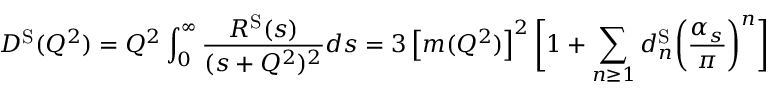<formula> <loc_0><loc_0><loc_500><loc_500>D ^ { S } ( Q ^ { 2 } ) = Q ^ { 2 } \int _ { 0 } ^ { \infty } \frac { R ^ { S } ( s ) } { ( s + Q ^ { 2 } ) ^ { 2 } } d s = 3 \left [ m ( Q ^ { 2 } ) \right ] ^ { 2 } \left [ 1 + \sum _ { n \geq 1 } d _ { n } ^ { S } \left ( \frac { \alpha _ { s } } { \pi } \right ) ^ { n } \right ]</formula> 